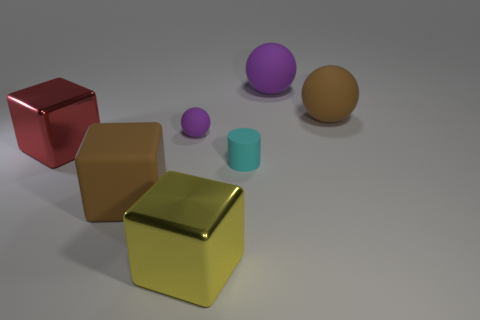Subtract all large matte spheres. How many spheres are left? 1 Add 2 large purple balls. How many objects exist? 9 Subtract all balls. How many objects are left? 4 Add 1 yellow metallic blocks. How many yellow metallic blocks are left? 2 Add 2 tiny purple rubber objects. How many tiny purple rubber objects exist? 3 Subtract 1 purple spheres. How many objects are left? 6 Subtract all tiny matte things. Subtract all metal cubes. How many objects are left? 3 